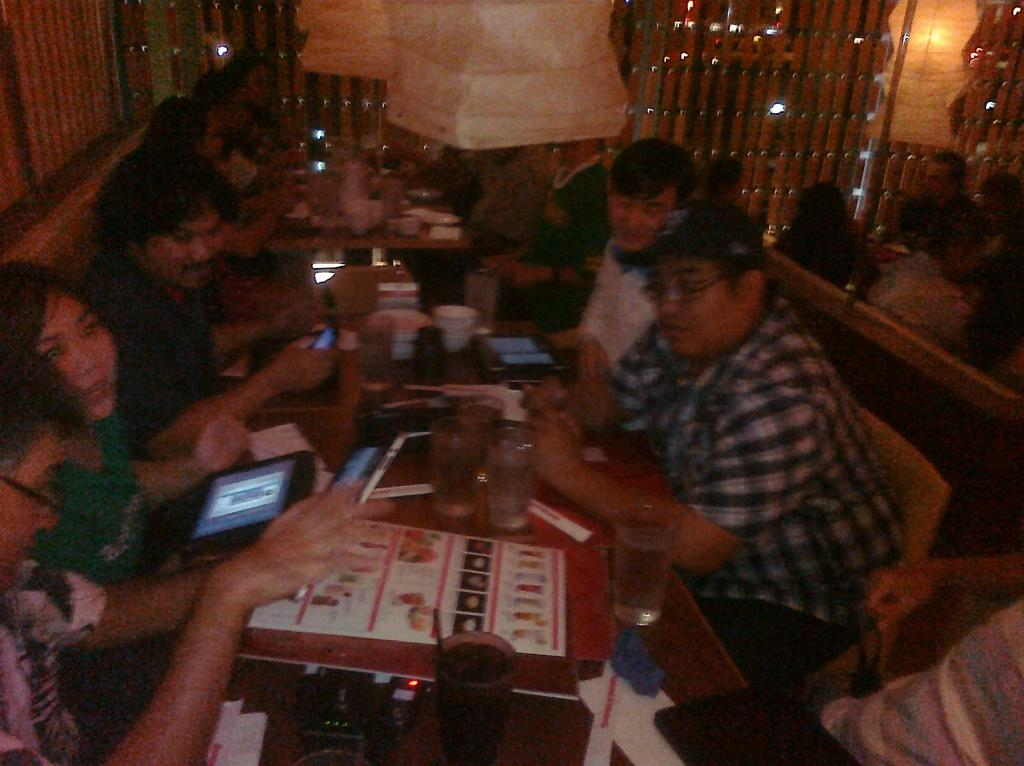What are the people in the image doing? The people in the image are sitting. Where are the people sitting in relation to the tables? The people are sitting in front of the tables. What can be seen on the tables in the image? There are glasses and other objects on the tables. What can be seen in the background of the image? There are lights and other objects visible in the background. What type of alarm is ringing in the image? There is no alarm present in the image. What kind of beef is being served on the tables in the image? There is no beef present in the image; only glasses and other objects are visible on the tables. 